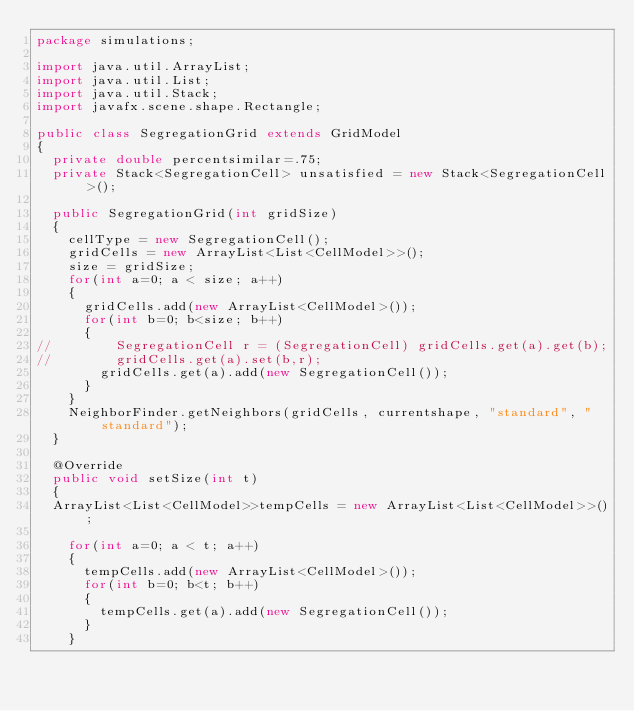Convert code to text. <code><loc_0><loc_0><loc_500><loc_500><_Java_>package simulations;

import java.util.ArrayList;
import java.util.List;
import java.util.Stack;
import javafx.scene.shape.Rectangle;

public class SegregationGrid extends GridModel
{
	private double percentsimilar=.75;
	private Stack<SegregationCell> unsatisfied = new Stack<SegregationCell>();
	
	public SegregationGrid(int gridSize)
	{
		cellType = new SegregationCell();
		gridCells = new ArrayList<List<CellModel>>();
		size = gridSize;
		for(int a=0; a < size; a++)
		{
			gridCells.add(new ArrayList<CellModel>());
			for(int b=0; b<size; b++)
			{
//				SegregationCell r = (SegregationCell) gridCells.get(a).get(b);
//				gridCells.get(a).set(b,r);
				gridCells.get(a).add(new SegregationCell());
			}
		}
		NeighborFinder.getNeighbors(gridCells, currentshape, "standard", "standard");	
	}
	
	@Override
	public void setSize(int t)
	{
	ArrayList<List<CellModel>>tempCells = new ArrayList<List<CellModel>>();
		
		for(int a=0; a < t; a++)
		{
			tempCells.add(new ArrayList<CellModel>());
			for(int b=0; b<t; b++)
			{
				tempCells.get(a).add(new SegregationCell());
			}
		}</code> 